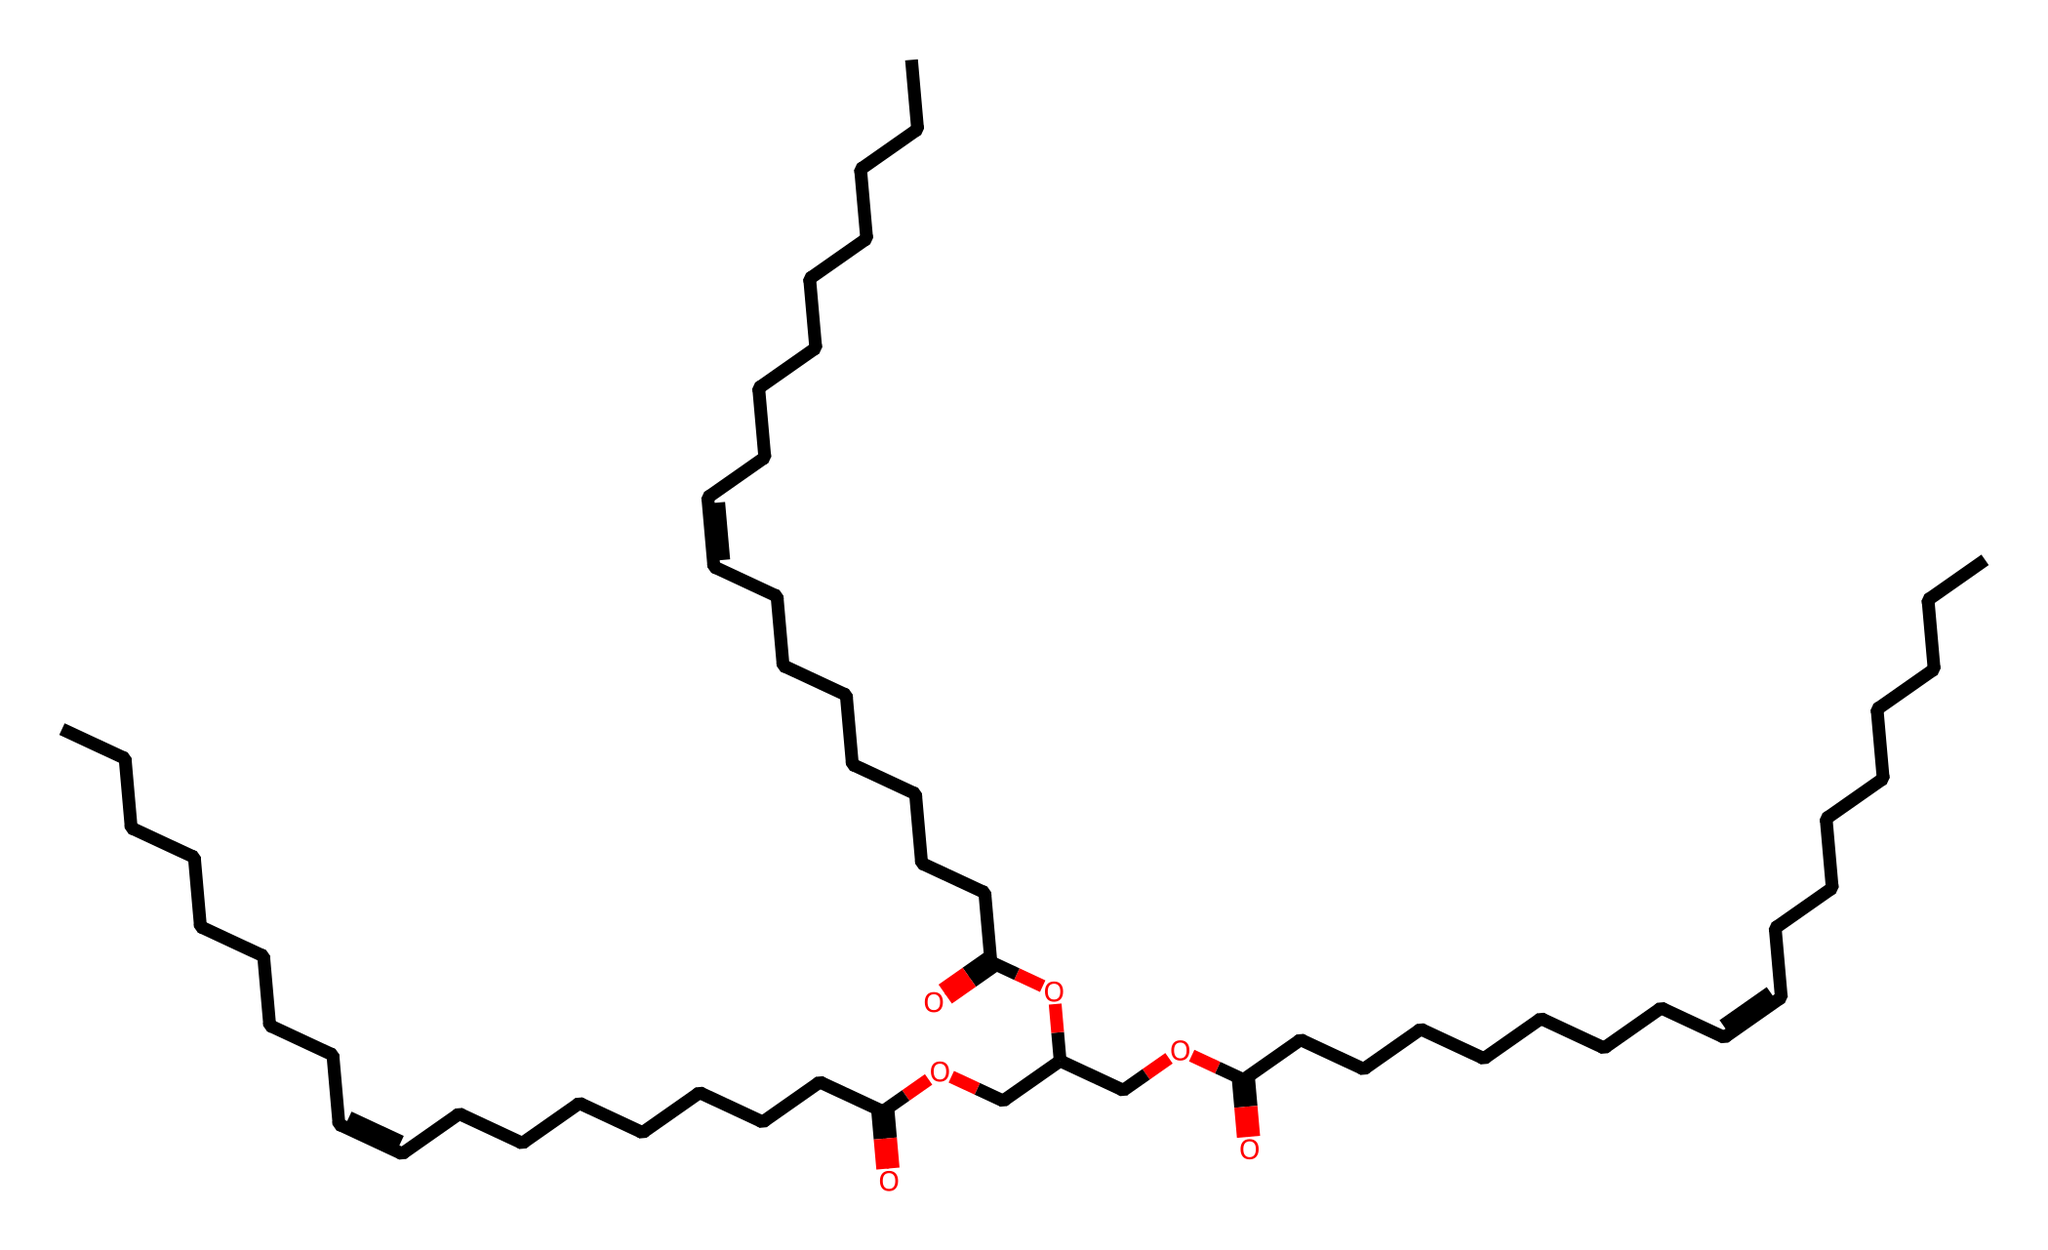What is the longest carbon chain in this molecule? By examining the structure represented by the SMILES notation, one can identify the longest continuous chain of carbon atoms without branching or interruptions. In this structure, the longest chain consists of 18 carbon atoms.
Answer: 18 How many double bonds are present in this structure? The structure contains multiple sections that indicate unsaturation through the presence of "C=C" in the SMILES representation. Counting these segments reveals that there are 3 double bonds.
Answer: 3 What functional group is present at the end of this molecule? By observing the terminal part of the chemical structure, we can recognize that there is a carboxylic acid group (-COOH) due to the presence of the carbonyl and hydroxyl groups connected to the same carbon.
Answer: carboxylic acid What type of compound is this chemical classified as? Given its structure and functional groups, this compound can be classified based on its usage and characteristics. The presence of vegetable oil components and the emphasis on biodegradable aspects suggest it is an ester-based lubricant.
Answer: ester-based lubricant Does this chemical structure contain any branched components? Analyzing the chain structure reveals that all components are part of long linear chains without notable branching points. Thus, the presence of branching can be ruled out in this molecular configuration.
Answer: no How would you categorize the polarity of this lubricant? By assessing the presence of polar functional groups, such as the carboxylic acid, in conjunction with the long non-polar hydrocarbon chains, we can determine that this lubricant exhibits amphiphilic properties, making it partly polar.
Answer: amphiphilic 